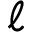<formula> <loc_0><loc_0><loc_500><loc_500>\ell</formula> 